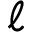<formula> <loc_0><loc_0><loc_500><loc_500>\ell</formula> 